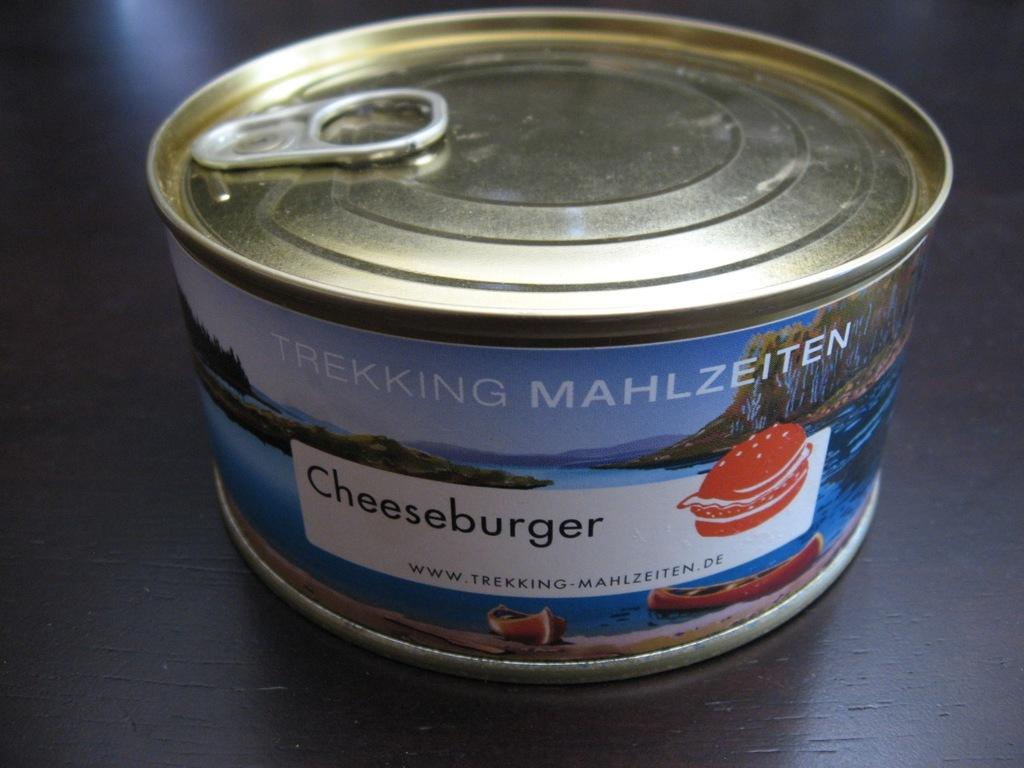<image>
Relay a brief, clear account of the picture shown. Small can of cheeseburger by a company named Trekking Mahlzeiten. 